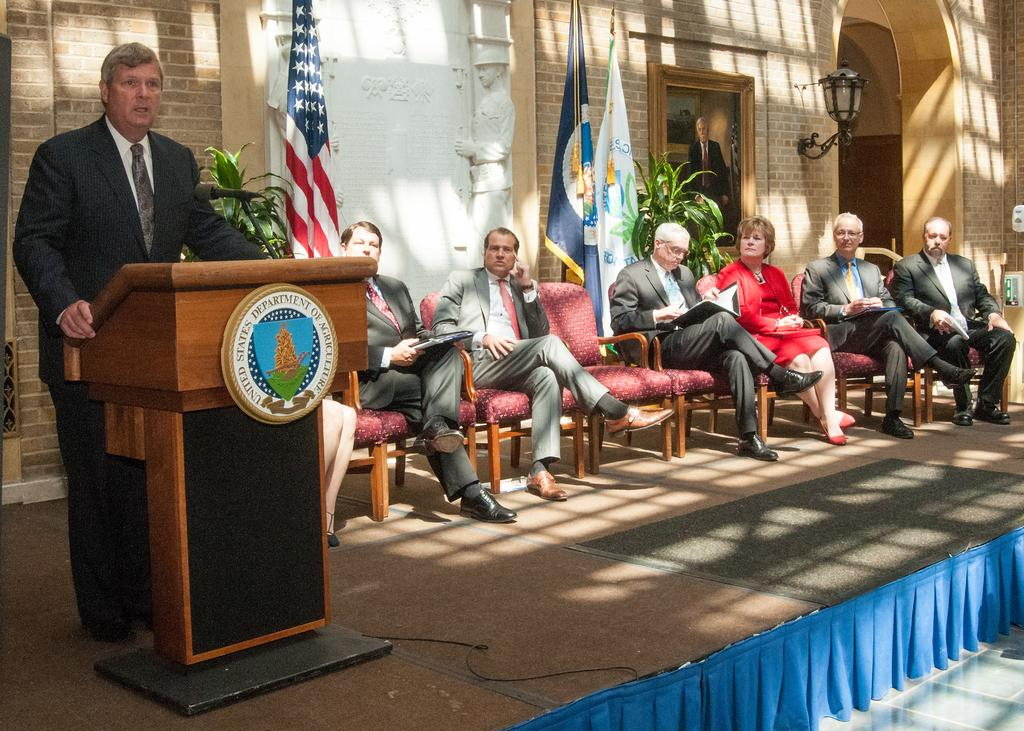What are the people in the image doing? The people in the image are sitting in chairs in front of a building. Is there anyone in the image who is not sitting? Yes, one person is standing and talking with the help of a microphone. What type of road can be seen in the image? There is no road visible in the image; it features people sitting in chairs and one person standing with a microphone in front of a building. Is there an army present in the image? There is no army present in the image. 